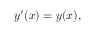<formula> <loc_0><loc_0><loc_500><loc_500>y ^ { \prime } ( x ) = y ( x ) ,</formula> 